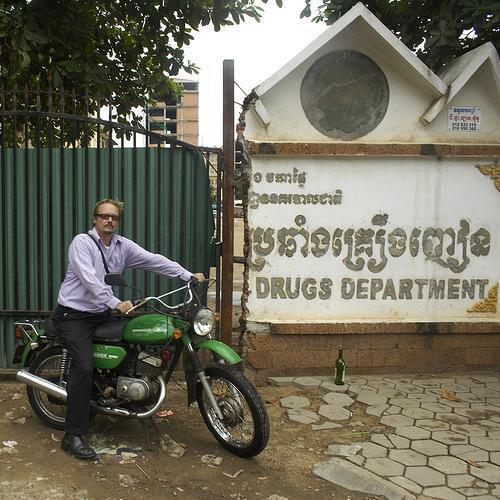How many chairs are on the right side of the tree?
Give a very brief answer. 0. 